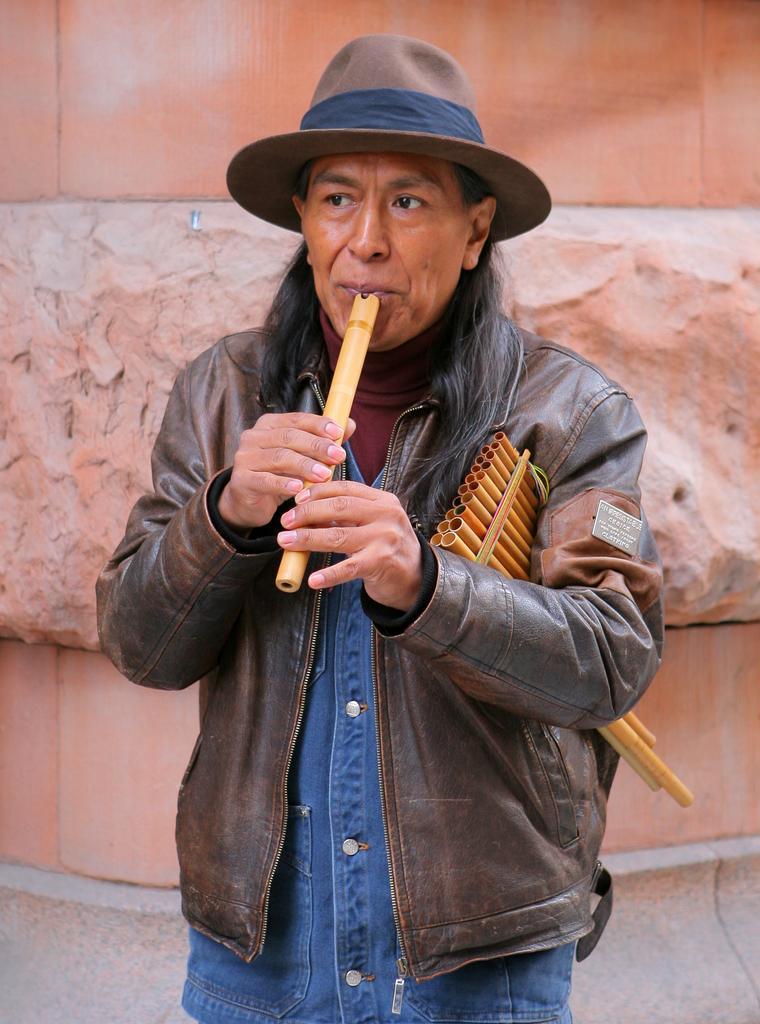In one or two sentences, can you explain what this image depicts? In this picture is a man playing a flute holding with his both hands is wearing a cap 